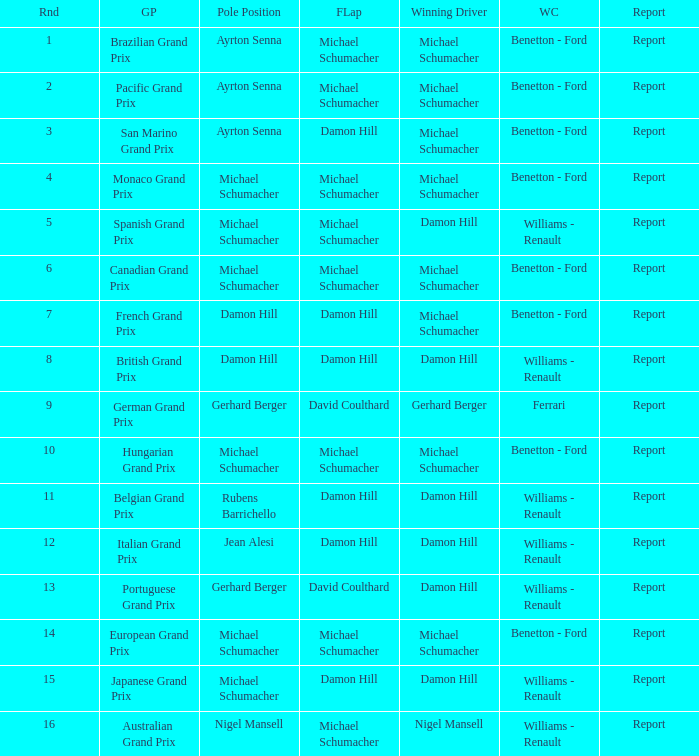Write the full table. {'header': ['Rnd', 'GP', 'Pole Position', 'FLap', 'Winning Driver', 'WC', 'Report'], 'rows': [['1', 'Brazilian Grand Prix', 'Ayrton Senna', 'Michael Schumacher', 'Michael Schumacher', 'Benetton - Ford', 'Report'], ['2', 'Pacific Grand Prix', 'Ayrton Senna', 'Michael Schumacher', 'Michael Schumacher', 'Benetton - Ford', 'Report'], ['3', 'San Marino Grand Prix', 'Ayrton Senna', 'Damon Hill', 'Michael Schumacher', 'Benetton - Ford', 'Report'], ['4', 'Monaco Grand Prix', 'Michael Schumacher', 'Michael Schumacher', 'Michael Schumacher', 'Benetton - Ford', 'Report'], ['5', 'Spanish Grand Prix', 'Michael Schumacher', 'Michael Schumacher', 'Damon Hill', 'Williams - Renault', 'Report'], ['6', 'Canadian Grand Prix', 'Michael Schumacher', 'Michael Schumacher', 'Michael Schumacher', 'Benetton - Ford', 'Report'], ['7', 'French Grand Prix', 'Damon Hill', 'Damon Hill', 'Michael Schumacher', 'Benetton - Ford', 'Report'], ['8', 'British Grand Prix', 'Damon Hill', 'Damon Hill', 'Damon Hill', 'Williams - Renault', 'Report'], ['9', 'German Grand Prix', 'Gerhard Berger', 'David Coulthard', 'Gerhard Berger', 'Ferrari', 'Report'], ['10', 'Hungarian Grand Prix', 'Michael Schumacher', 'Michael Schumacher', 'Michael Schumacher', 'Benetton - Ford', 'Report'], ['11', 'Belgian Grand Prix', 'Rubens Barrichello', 'Damon Hill', 'Damon Hill', 'Williams - Renault', 'Report'], ['12', 'Italian Grand Prix', 'Jean Alesi', 'Damon Hill', 'Damon Hill', 'Williams - Renault', 'Report'], ['13', 'Portuguese Grand Prix', 'Gerhard Berger', 'David Coulthard', 'Damon Hill', 'Williams - Renault', 'Report'], ['14', 'European Grand Prix', 'Michael Schumacher', 'Michael Schumacher', 'Michael Schumacher', 'Benetton - Ford', 'Report'], ['15', 'Japanese Grand Prix', 'Michael Schumacher', 'Damon Hill', 'Damon Hill', 'Williams - Renault', 'Report'], ['16', 'Australian Grand Prix', 'Nigel Mansell', 'Michael Schumacher', 'Nigel Mansell', 'Williams - Renault', 'Report']]} Name the fastest lap for the brazilian grand prix Michael Schumacher. 